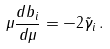Convert formula to latex. <formula><loc_0><loc_0><loc_500><loc_500>\mu \frac { d b _ { i } } { d \mu } = - 2 \tilde { \gamma } _ { i } \, .</formula> 